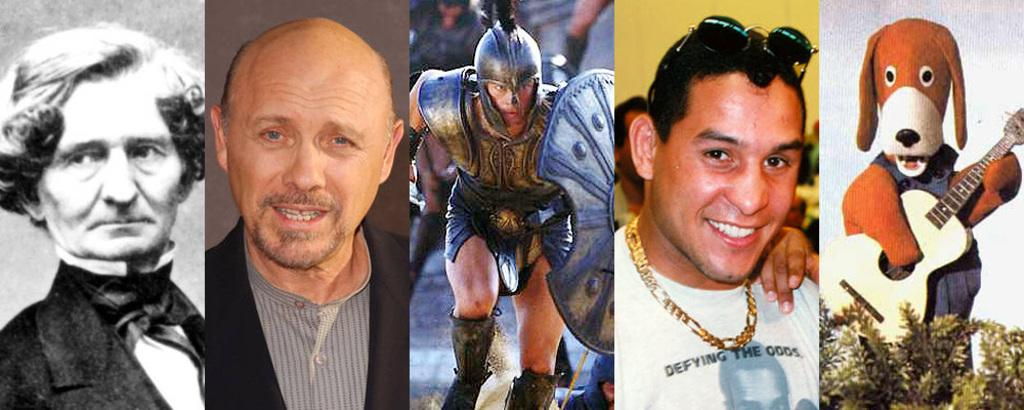What type of visual composition is present in the image? The image contains a collage of pictures. What subjects are depicted in the collage? Some of the pictures in the collage depict people, while others depict cartoons. What type of science experiment can be seen in the image? There is no science experiment present in the image; it contains a collage of pictures depicting people and cartoons. 